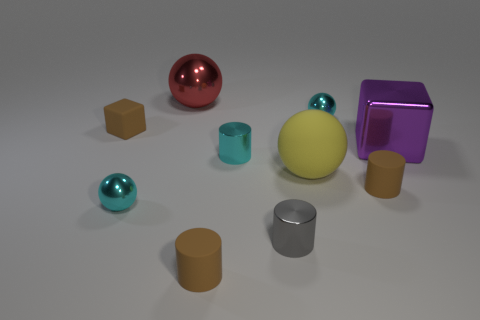What is the size of the brown object that is in front of the metal block and behind the gray metallic cylinder?
Provide a short and direct response. Small. What shape is the tiny brown rubber thing that is in front of the gray shiny cylinder?
Provide a succinct answer. Cylinder. Does the tiny cube have the same material as the cyan ball that is right of the matte ball?
Ensure brevity in your answer.  No. Is the shape of the yellow thing the same as the small gray thing?
Give a very brief answer. No. There is a tiny cyan object that is the same shape as the small gray object; what is it made of?
Keep it short and to the point. Metal. There is a thing that is both in front of the tiny block and on the left side of the large red sphere; what color is it?
Keep it short and to the point. Cyan. The large rubber ball is what color?
Ensure brevity in your answer.  Yellow. Are there any purple objects that have the same shape as the big yellow matte thing?
Provide a succinct answer. No. What is the size of the brown matte object that is behind the purple metallic thing?
Offer a very short reply. Small. There is a purple cube that is the same size as the matte sphere; what is its material?
Give a very brief answer. Metal. 